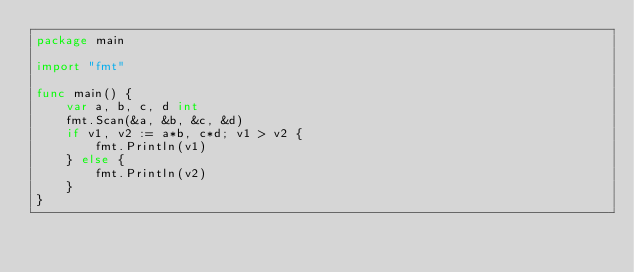Convert code to text. <code><loc_0><loc_0><loc_500><loc_500><_Go_>package main

import "fmt"

func main() {
	var a, b, c, d int
	fmt.Scan(&a, &b, &c, &d)
	if v1, v2 := a*b, c*d; v1 > v2 {
		fmt.Println(v1)
	} else {
		fmt.Println(v2)
	}
}
</code> 